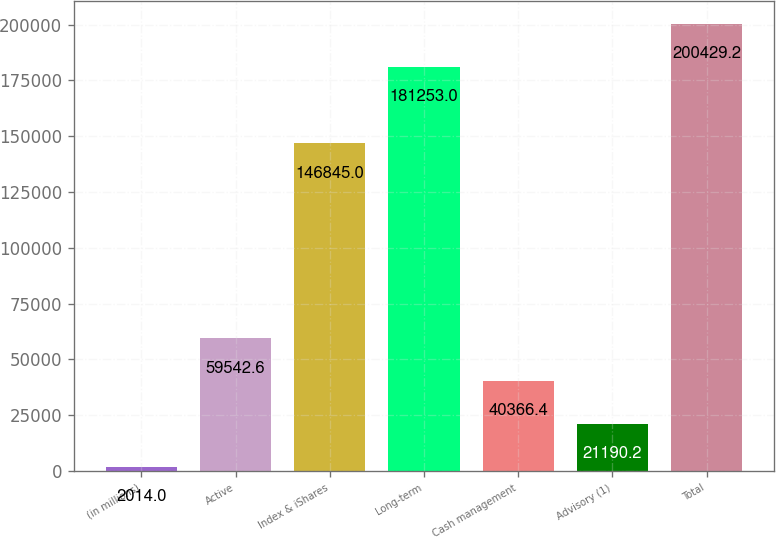Convert chart to OTSL. <chart><loc_0><loc_0><loc_500><loc_500><bar_chart><fcel>(in millions)<fcel>Active<fcel>Index & iShares<fcel>Long-term<fcel>Cash management<fcel>Advisory (1)<fcel>Total<nl><fcel>2014<fcel>59542.6<fcel>146845<fcel>181253<fcel>40366.4<fcel>21190.2<fcel>200429<nl></chart> 